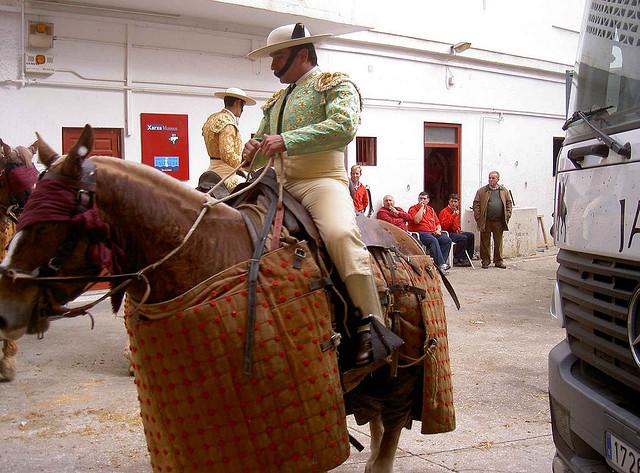What is covering the animal's eyes?
Quick response, please. Bandana. Is the closest rider wearing a hat?
Short answer required. Yes. What color is the horse?
Concise answer only. Brown. How many men have red shirts?
Quick response, please. 4. 